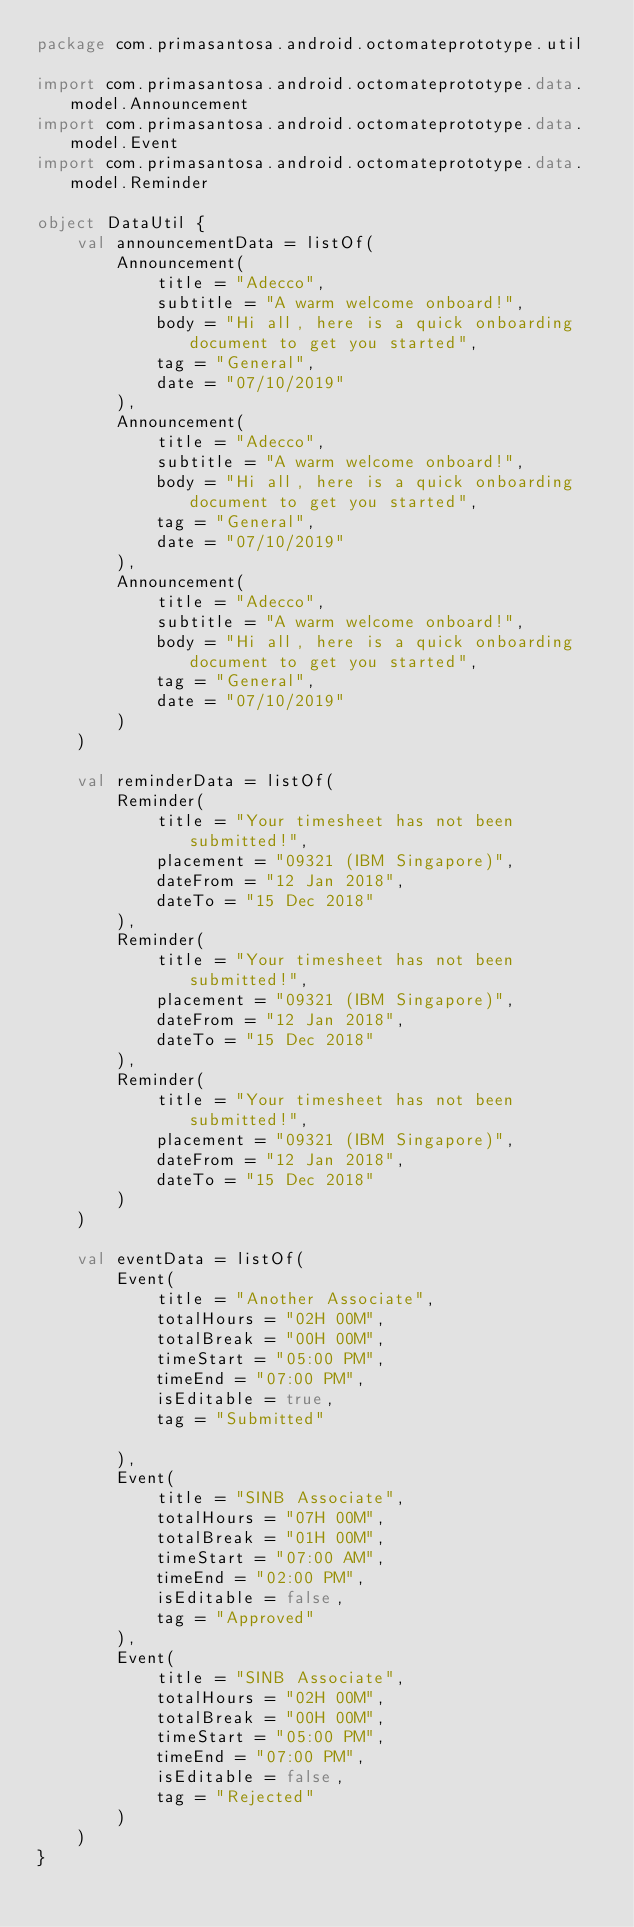Convert code to text. <code><loc_0><loc_0><loc_500><loc_500><_Kotlin_>package com.primasantosa.android.octomateprototype.util

import com.primasantosa.android.octomateprototype.data.model.Announcement
import com.primasantosa.android.octomateprototype.data.model.Event
import com.primasantosa.android.octomateprototype.data.model.Reminder

object DataUtil {
    val announcementData = listOf(
        Announcement(
            title = "Adecco",
            subtitle = "A warm welcome onboard!",
            body = "Hi all, here is a quick onboarding document to get you started",
            tag = "General",
            date = "07/10/2019"
        ),
        Announcement(
            title = "Adecco",
            subtitle = "A warm welcome onboard!",
            body = "Hi all, here is a quick onboarding document to get you started",
            tag = "General",
            date = "07/10/2019"
        ),
        Announcement(
            title = "Adecco",
            subtitle = "A warm welcome onboard!",
            body = "Hi all, here is a quick onboarding document to get you started",
            tag = "General",
            date = "07/10/2019"
        )
    )

    val reminderData = listOf(
        Reminder(
            title = "Your timesheet has not been submitted!",
            placement = "09321 (IBM Singapore)",
            dateFrom = "12 Jan 2018",
            dateTo = "15 Dec 2018"
        ),
        Reminder(
            title = "Your timesheet has not been submitted!",
            placement = "09321 (IBM Singapore)",
            dateFrom = "12 Jan 2018",
            dateTo = "15 Dec 2018"
        ),
        Reminder(
            title = "Your timesheet has not been submitted!",
            placement = "09321 (IBM Singapore)",
            dateFrom = "12 Jan 2018",
            dateTo = "15 Dec 2018"
        )
    )

    val eventData = listOf(
        Event(
            title = "Another Associate",
            totalHours = "02H 00M",
            totalBreak = "00H 00M",
            timeStart = "05:00 PM",
            timeEnd = "07:00 PM",
            isEditable = true,
            tag = "Submitted"

        ),
        Event(
            title = "SINB Associate",
            totalHours = "07H 00M",
            totalBreak = "01H 00M",
            timeStart = "07:00 AM",
            timeEnd = "02:00 PM",
            isEditable = false,
            tag = "Approved"
        ),
        Event(
            title = "SINB Associate",
            totalHours = "02H 00M",
            totalBreak = "00H 00M",
            timeStart = "05:00 PM",
            timeEnd = "07:00 PM",
            isEditable = false,
            tag = "Rejected"
        )
    )
}</code> 